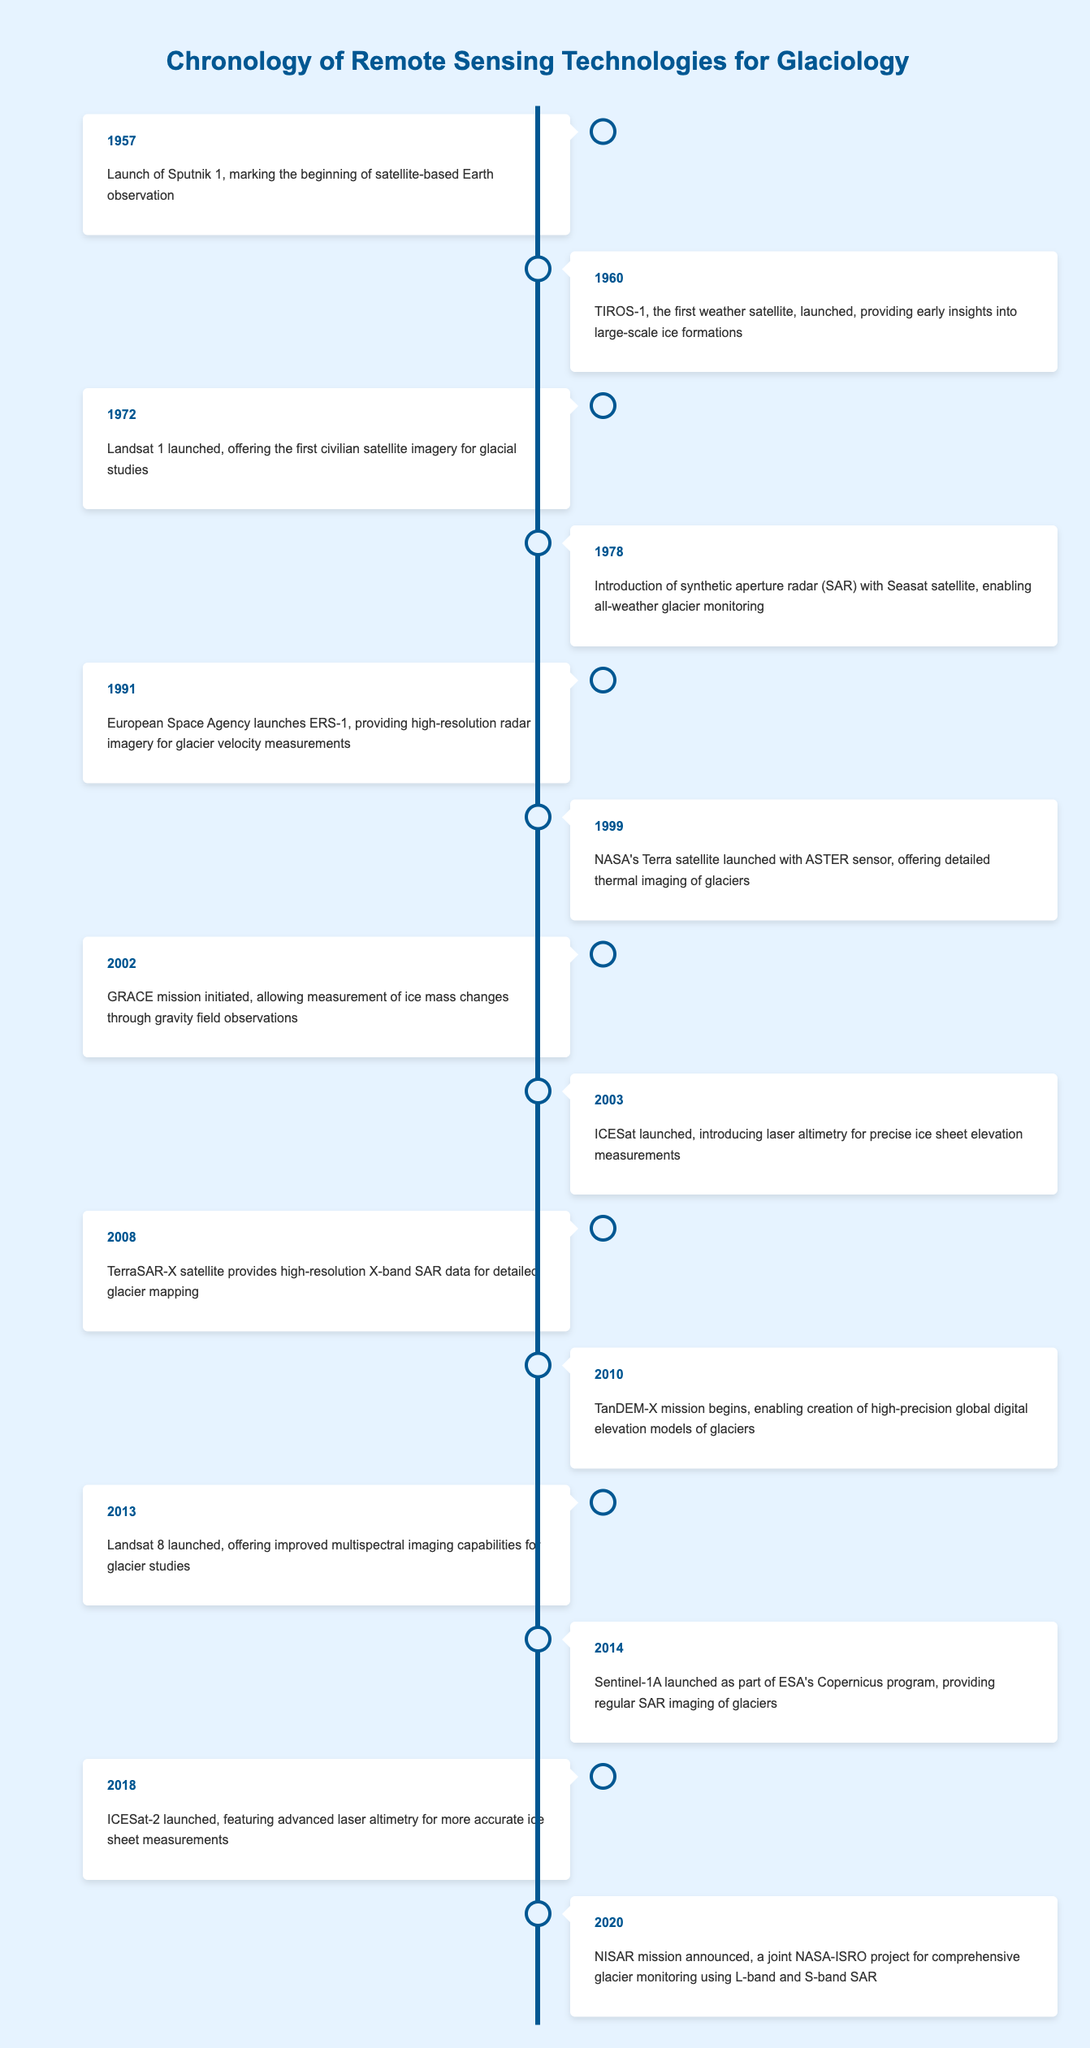What year was the launch of Landsat 1? Landsat 1 was launched in 1972 according to the entry in the table.
Answer: 1972 Which event occurred first, the launch of ICESat or the European Space Agency launching ERS-1? ICESat was launched in 2003, while ERS-1 was launched in 1991. Since 1991 is earlier than 2003, ERS-1 was the first event.
Answer: ERS-1 How many years passed between the launch of TIROS-1 and ICESat? TIROS-1 was launched in 1960 and ICESat in 2003. Therefore, the difference is 2003 - 1960 = 43 years.
Answer: 43 years Did the introduction of SAR technology occur before or after the launch of the first civilian satellite imagery? The introduction of SAR technology with the Seasat satellite was in 1978, which is after the launch of Landsat 1 in 1972. Therefore, SAR came after the first civilian imagery.
Answer: After What is the number of events listed between the years 2000 and 2010? The events listed from 2000 to 2010 include GRACE (2002), ICESat (2003), TerraSAR-X (2008), and TanDEM-X (2010), totaling 4 events.
Answer: 4 Which technology introduced laser altimetry for precise ice sheet elevation measurements? ICESat, launched in 2003, introduced laser altimetry for precise ice sheet measurements according to the table.
Answer: ICESat What was the primary purpose of the GRACE mission initiated in 2002? The GRACE mission allowed measurement of ice mass changes through gravity field observations, as stated in the table.
Answer: Measuring ice mass changes Which satellite was launched last according to the events listed? The last event listed in the table is the NISAR mission announced in 2020, which is the most recent event chronologically.
Answer: NISAR mission 